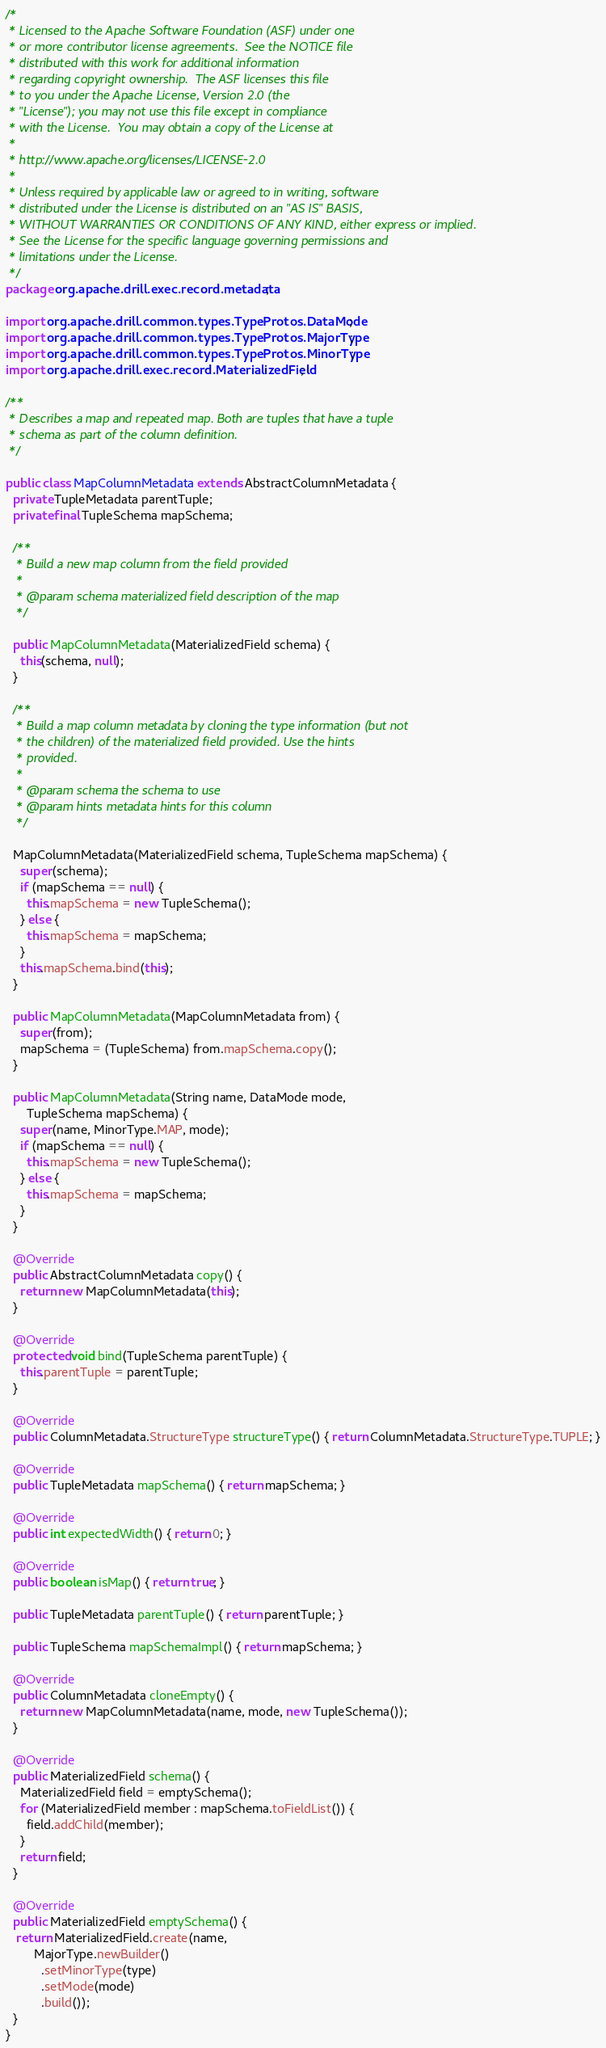Convert code to text. <code><loc_0><loc_0><loc_500><loc_500><_Java_>/*
 * Licensed to the Apache Software Foundation (ASF) under one
 * or more contributor license agreements.  See the NOTICE file
 * distributed with this work for additional information
 * regarding copyright ownership.  The ASF licenses this file
 * to you under the Apache License, Version 2.0 (the
 * "License"); you may not use this file except in compliance
 * with the License.  You may obtain a copy of the License at
 *
 * http://www.apache.org/licenses/LICENSE-2.0
 *
 * Unless required by applicable law or agreed to in writing, software
 * distributed under the License is distributed on an "AS IS" BASIS,
 * WITHOUT WARRANTIES OR CONDITIONS OF ANY KIND, either express or implied.
 * See the License for the specific language governing permissions and
 * limitations under the License.
 */
package org.apache.drill.exec.record.metadata;

import org.apache.drill.common.types.TypeProtos.DataMode;
import org.apache.drill.common.types.TypeProtos.MajorType;
import org.apache.drill.common.types.TypeProtos.MinorType;
import org.apache.drill.exec.record.MaterializedField;

/**
 * Describes a map and repeated map. Both are tuples that have a tuple
 * schema as part of the column definition.
 */

public class MapColumnMetadata extends AbstractColumnMetadata {
  private TupleMetadata parentTuple;
  private final TupleSchema mapSchema;

  /**
   * Build a new map column from the field provided
   *
   * @param schema materialized field description of the map
   */

  public MapColumnMetadata(MaterializedField schema) {
    this(schema, null);
  }

  /**
   * Build a map column metadata by cloning the type information (but not
   * the children) of the materialized field provided. Use the hints
   * provided.
   *
   * @param schema the schema to use
   * @param hints metadata hints for this column
   */

  MapColumnMetadata(MaterializedField schema, TupleSchema mapSchema) {
    super(schema);
    if (mapSchema == null) {
      this.mapSchema = new TupleSchema();
    } else {
      this.mapSchema = mapSchema;
    }
    this.mapSchema.bind(this);
  }

  public MapColumnMetadata(MapColumnMetadata from) {
    super(from);
    mapSchema = (TupleSchema) from.mapSchema.copy();
  }

  public MapColumnMetadata(String name, DataMode mode,
      TupleSchema mapSchema) {
    super(name, MinorType.MAP, mode);
    if (mapSchema == null) {
      this.mapSchema = new TupleSchema();
    } else {
      this.mapSchema = mapSchema;
    }
  }

  @Override
  public AbstractColumnMetadata copy() {
    return new MapColumnMetadata(this);
  }

  @Override
  protected void bind(TupleSchema parentTuple) {
    this.parentTuple = parentTuple;
  }

  @Override
  public ColumnMetadata.StructureType structureType() { return ColumnMetadata.StructureType.TUPLE; }

  @Override
  public TupleMetadata mapSchema() { return mapSchema; }

  @Override
  public int expectedWidth() { return 0; }

  @Override
  public boolean isMap() { return true; }

  public TupleMetadata parentTuple() { return parentTuple; }

  public TupleSchema mapSchemaImpl() { return mapSchema; }

  @Override
  public ColumnMetadata cloneEmpty() {
    return new MapColumnMetadata(name, mode, new TupleSchema());
  }

  @Override
  public MaterializedField schema() {
    MaterializedField field = emptySchema();
    for (MaterializedField member : mapSchema.toFieldList()) {
      field.addChild(member);
    }
    return field;
  }

  @Override
  public MaterializedField emptySchema() {
   return MaterializedField.create(name,
        MajorType.newBuilder()
          .setMinorType(type)
          .setMode(mode)
          .build());
  }
}</code> 